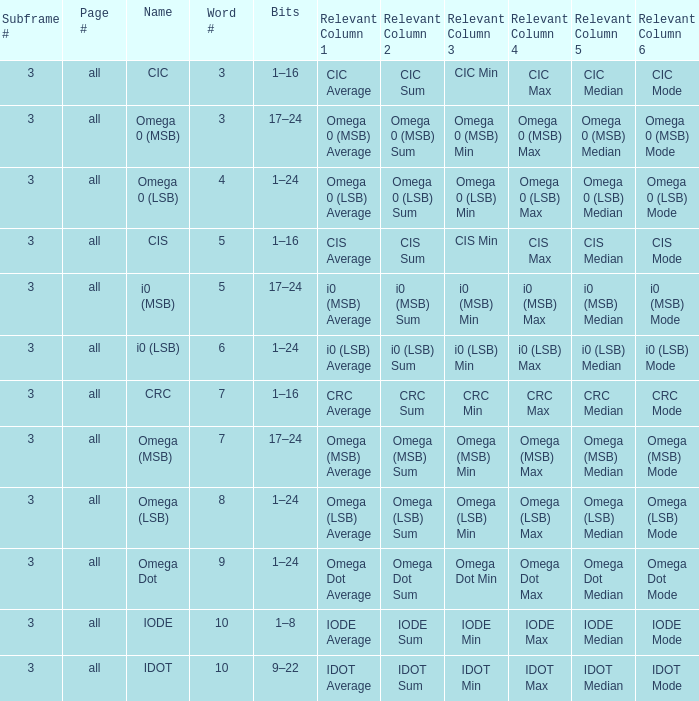What is the word number known as omega dot? 9.0. 